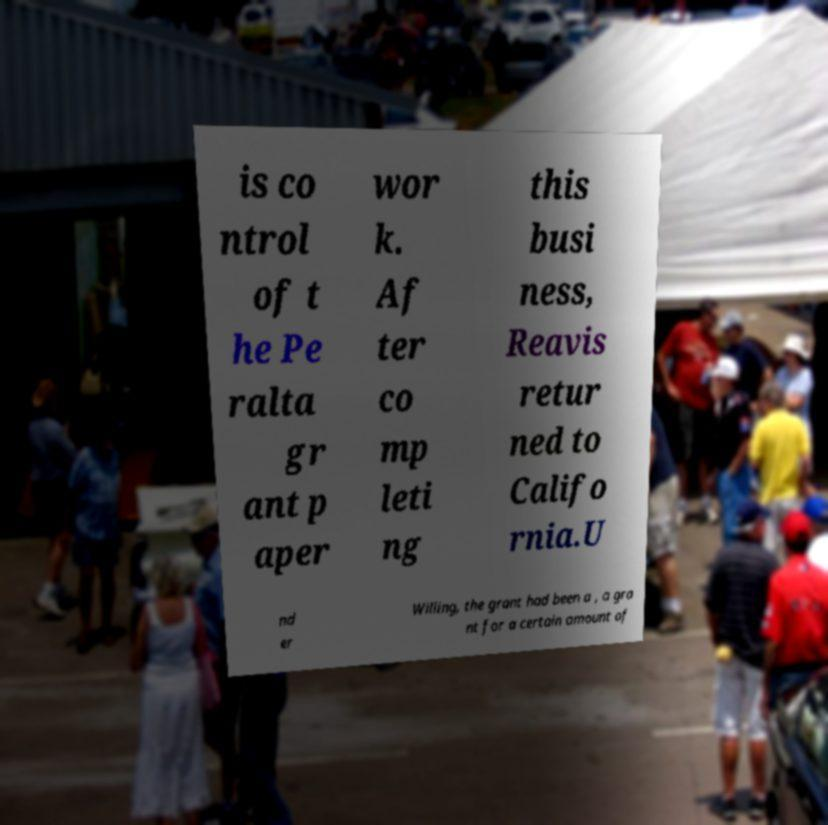For documentation purposes, I need the text within this image transcribed. Could you provide that? is co ntrol of t he Pe ralta gr ant p aper wor k. Af ter co mp leti ng this busi ness, Reavis retur ned to Califo rnia.U nd er Willing, the grant had been a , a gra nt for a certain amount of 